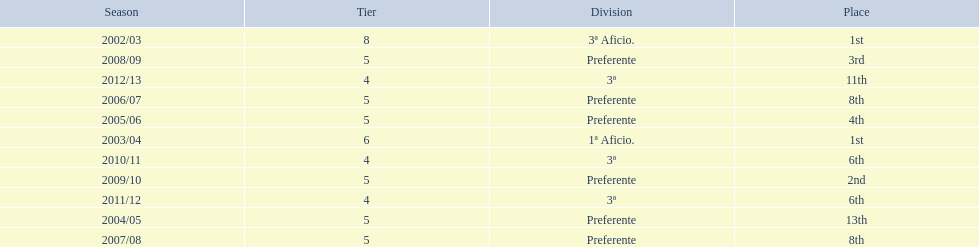How many times did  internacional de madrid cf come in 6th place? 6th, 6th. What is the first season that the team came in 6th place? 2010/11. Which season after the first did they place in 6th again? 2011/12. 